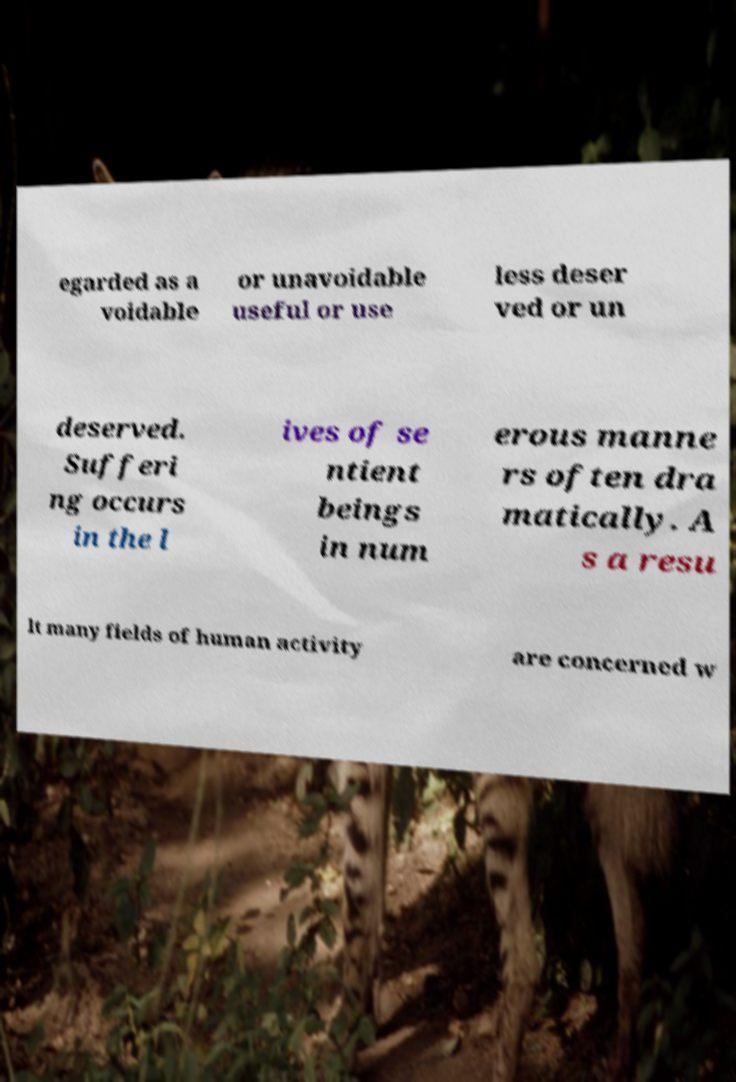What messages or text are displayed in this image? I need them in a readable, typed format. egarded as a voidable or unavoidable useful or use less deser ved or un deserved. Sufferi ng occurs in the l ives of se ntient beings in num erous manne rs often dra matically. A s a resu lt many fields of human activity are concerned w 